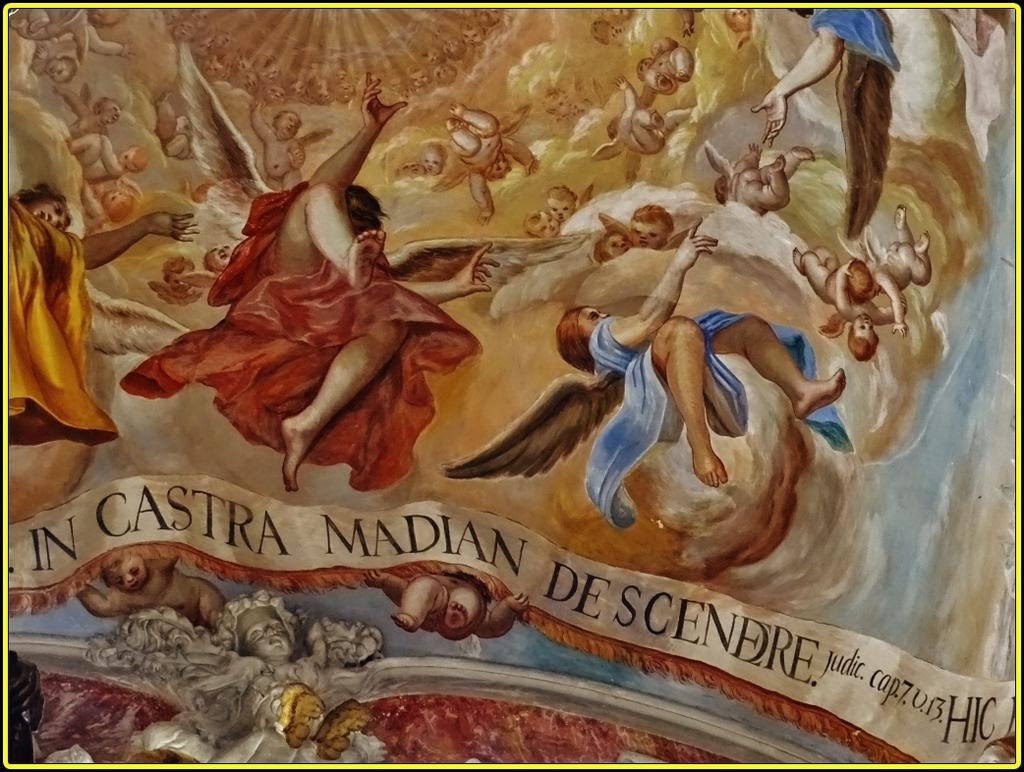<image>
Present a compact description of the photo's key features. In Castra Madian De Scendre art design with HIC logo. 